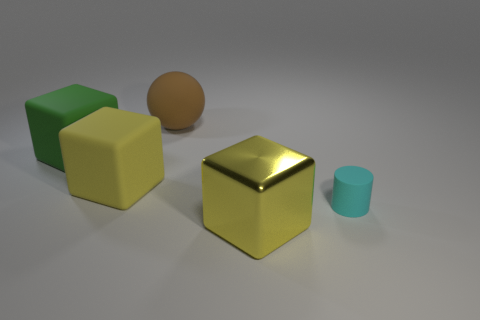There is a matte object that is to the right of the yellow rubber block and behind the cyan cylinder; what shape is it?
Ensure brevity in your answer.  Sphere. Is there a small matte cylinder right of the large yellow cube that is behind the yellow block that is right of the big sphere?
Offer a terse response. Yes. How many objects are big blocks that are behind the tiny cyan rubber thing or yellow cubes to the right of the big brown object?
Your answer should be compact. 3. Do the big object behind the big green rubber cube and the small cyan cylinder have the same material?
Provide a short and direct response. Yes. There is a large object that is right of the yellow rubber thing and behind the cyan thing; what material is it?
Offer a very short reply. Rubber. There is a big block to the left of the yellow block behind the large metallic thing; what color is it?
Provide a succinct answer. Green. There is a green thing that is the same shape as the large yellow metal thing; what is its material?
Keep it short and to the point. Rubber. There is a large matte block that is on the right side of the thing to the left of the yellow thing behind the yellow shiny block; what is its color?
Make the answer very short. Yellow. How many objects are either big matte cubes or rubber things?
Your answer should be compact. 4. How many other things have the same shape as the big shiny object?
Your answer should be very brief. 2. 